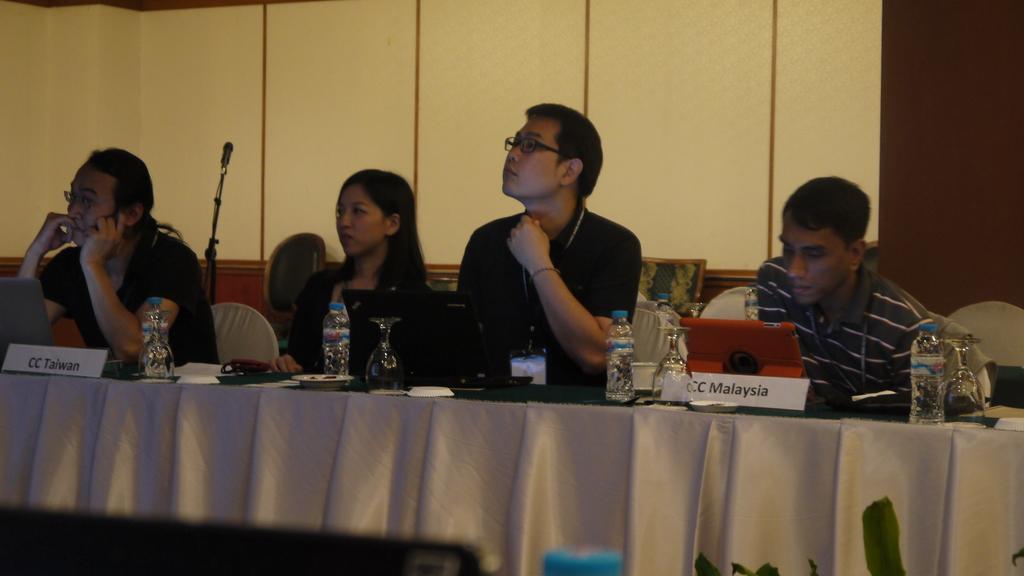In one or two sentences, can you explain what this image depicts? As we can see in the image there are four people who are sitting on the chair in front of them there is a water bottle kept and the wine glass which is kept up side down and the people are wearing the id cards and behind them there is a wall which is in cream colour and on the table its written "CC Malaysia" and "CC Taiwan". 